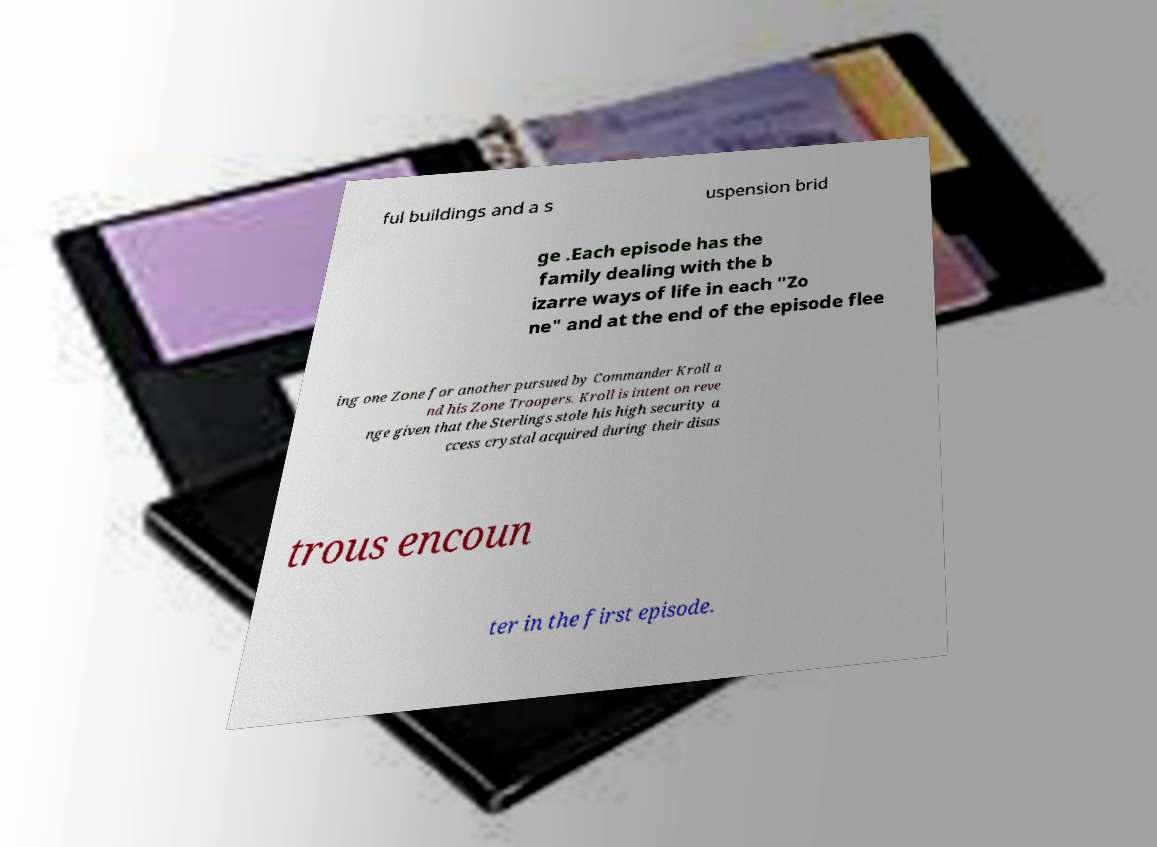Please identify and transcribe the text found in this image. ful buildings and a s uspension brid ge .Each episode has the family dealing with the b izarre ways of life in each "Zo ne" and at the end of the episode flee ing one Zone for another pursued by Commander Kroll a nd his Zone Troopers. Kroll is intent on reve nge given that the Sterlings stole his high security a ccess crystal acquired during their disas trous encoun ter in the first episode. 